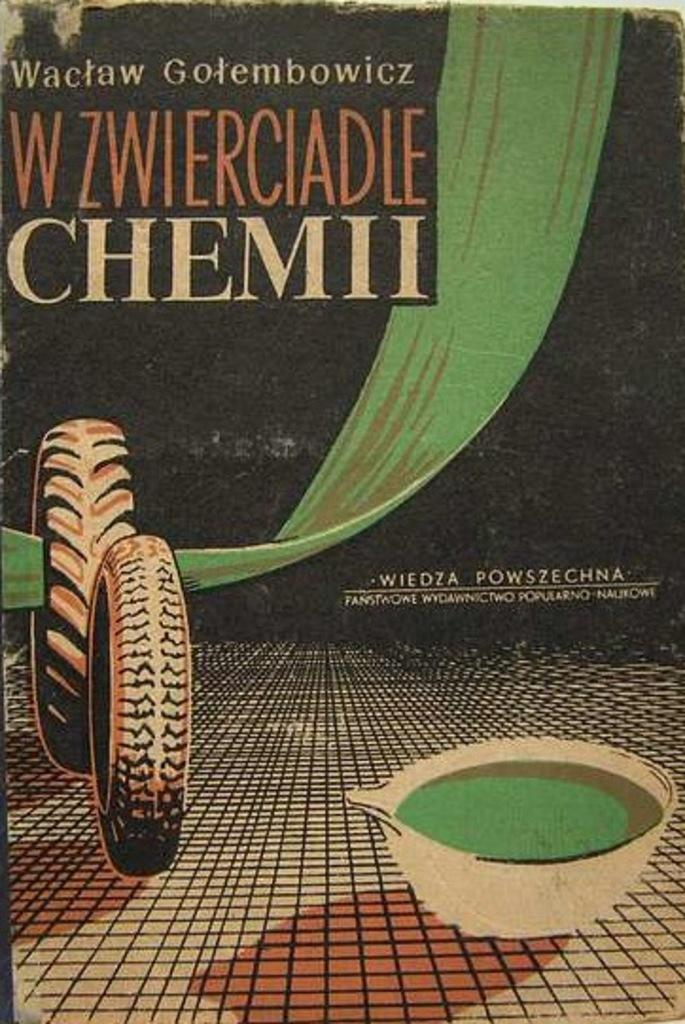What type of visual is the image? The image is a poster. What objects can be seen in the poster? There are tyres and a bowl in the image. What material is present in the image? There is cloth in the image. Are there any words or letters in the image? Yes, there is text in the image. How many roots can be seen growing from the bowl in the image? There are no roots present in the image; it features a bowl and tyres, among other items. What time of day is depicted in the image? The image does not depict a specific time of day, as it is a poster with various objects and text. 